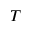<formula> <loc_0><loc_0><loc_500><loc_500>T</formula> 